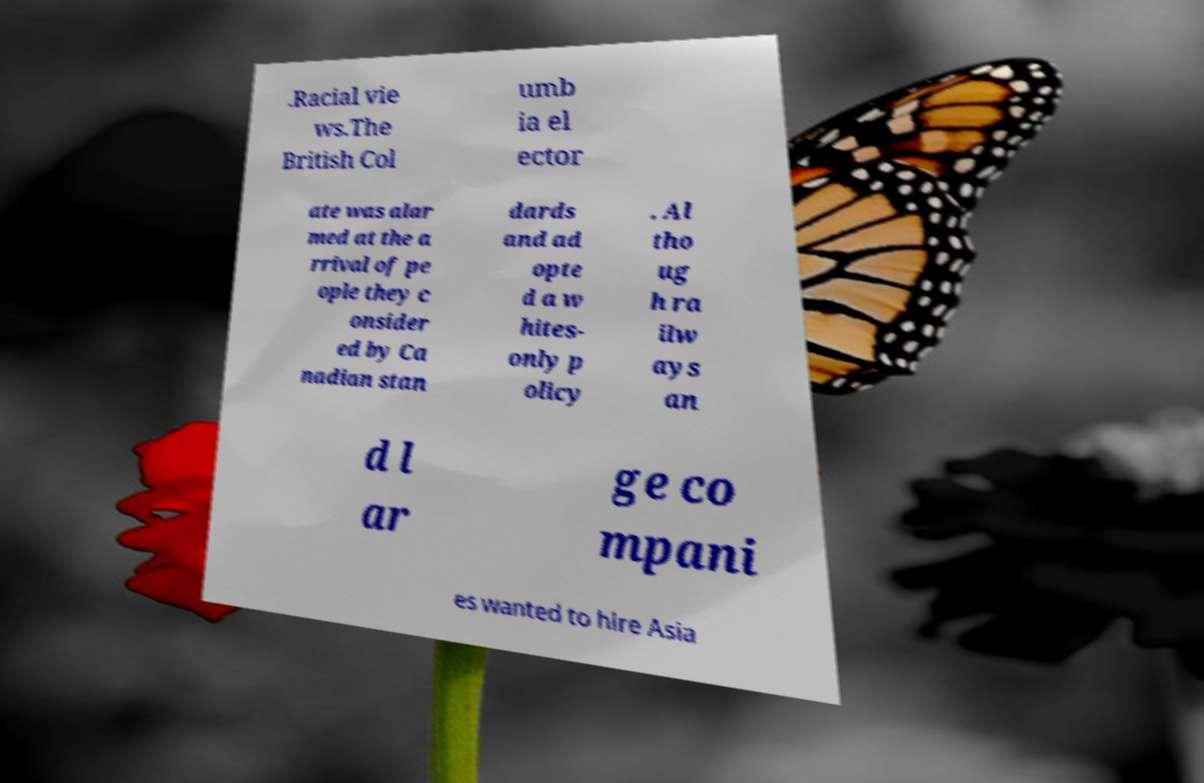Can you accurately transcribe the text from the provided image for me? .Racial vie ws.The British Col umb ia el ector ate was alar med at the a rrival of pe ople they c onsider ed by Ca nadian stan dards and ad opte d a w hites- only p olicy . Al tho ug h ra ilw ays an d l ar ge co mpani es wanted to hire Asia 